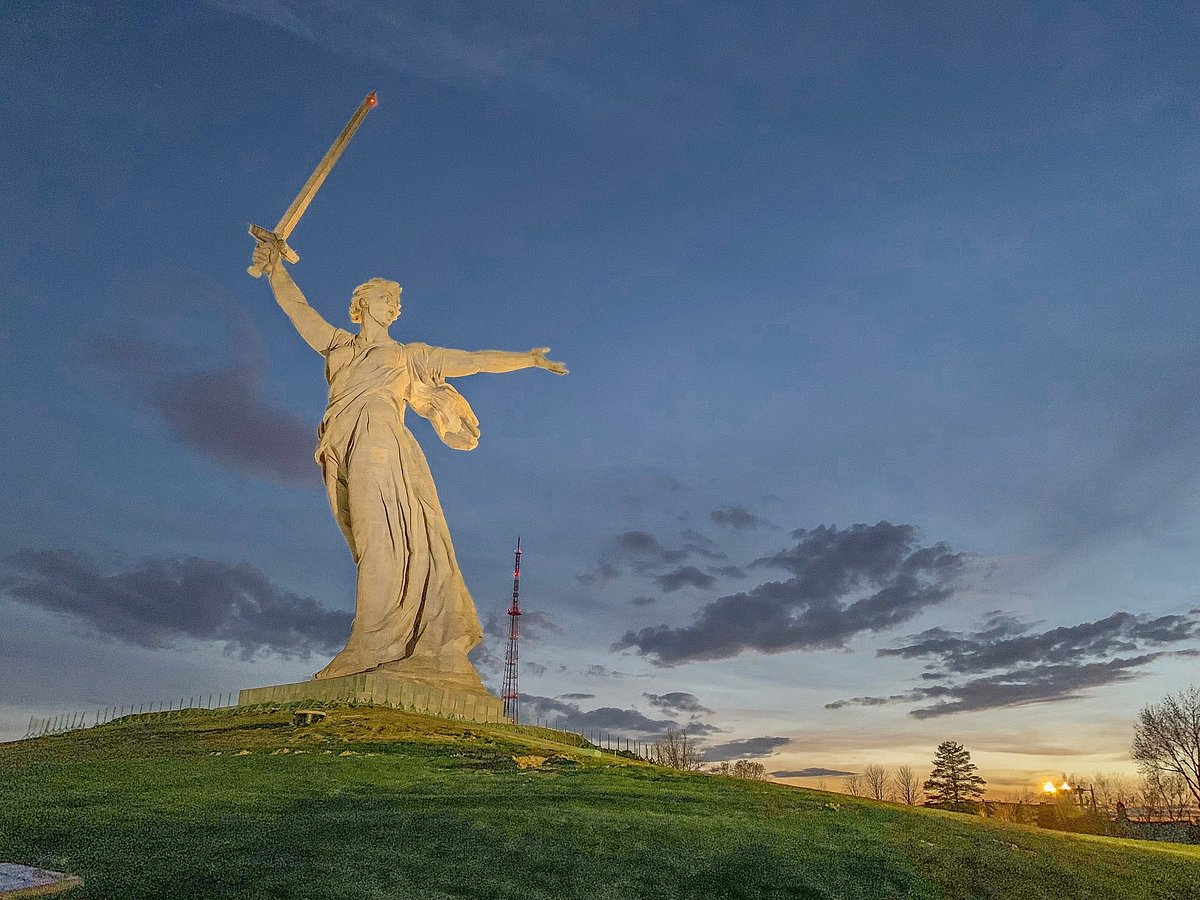Imagine you are the statue. What thoughts might be crossing your mind? As the statue, I stand tall and vigilant, a sentinel watching over the land I represent. My extended hand calls out, urging my people to remain steadfast and united in the face of challenges. Holding the sword high, I am a symbol of resilience and strength, reflecting on the sacrifices made during the turbulent past. The wind that whispers around me carries stories of valor, and the setting sun casts a golden glow on my form, illuminating the hope and indomitable spirit of my nation. Each day, as I gaze upon the changing sky, I am reminded of the enduring legacy I symbolize and the unwavering pride of my people. 